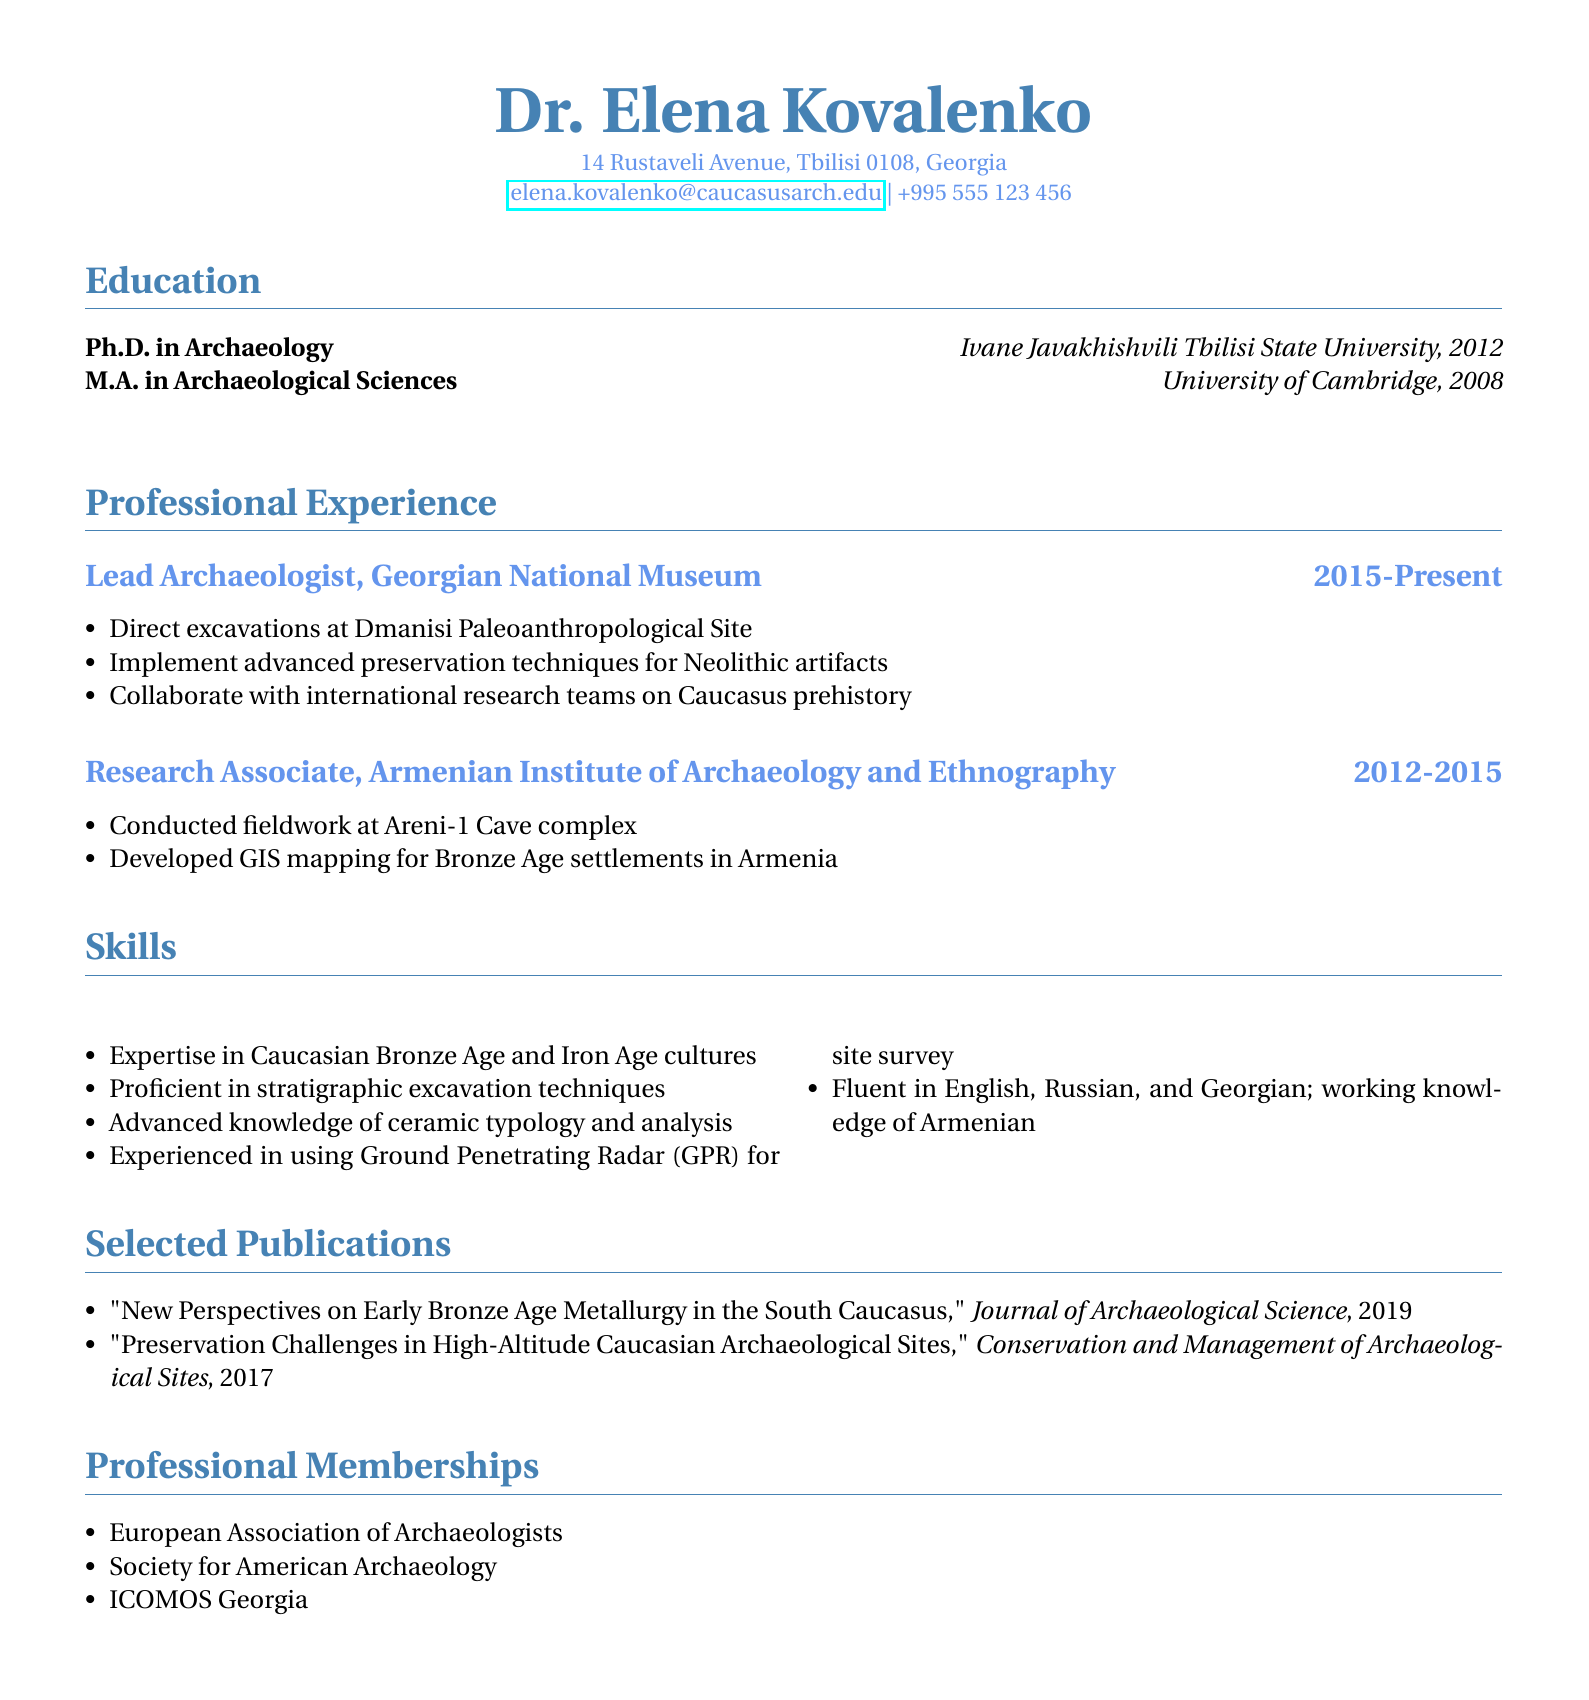What is the name of the lead archaeologist? The document provides the name of the lead archaeologist, which is Dr. Elena Kovalenko.
Answer: Dr. Elena Kovalenko Where does Dr. Elena Kovalenko work currently? The document states that Dr. Elena Kovalenko is currently employed at the Georgian National Museum.
Answer: Georgian National Museum What year did Dr. Kovalenko earn her Ph.D.? The document indicates that her Ph.D. was awarded in 2012.
Answer: 2012 Which archaeological site did Dr. Kovalenko direct excavations at? The document mentions that she directed excavations at the Dmanisi Paleoanthropological Site.
Answer: Dmanisi Paleoanthropological Site How many professional memberships does Dr. Kovalenko hold? The document lists three professional memberships under the relevant section.
Answer: Three What is Dr. Kovalenko's area of expertise? The document specifies her expertise in Caucasian Bronze Age and Iron Age cultures.
Answer: Caucasian Bronze Age and Iron Age cultures What advanced technology is Dr. Kovalenko experienced in using? The document states that she has experience using Ground Penetrating Radar for site survey.
Answer: Ground Penetrating Radar (GPR) In what year was her publication on preservation challenges released? The document states that the publication on preservation challenges was released in 2017.
Answer: 2017 